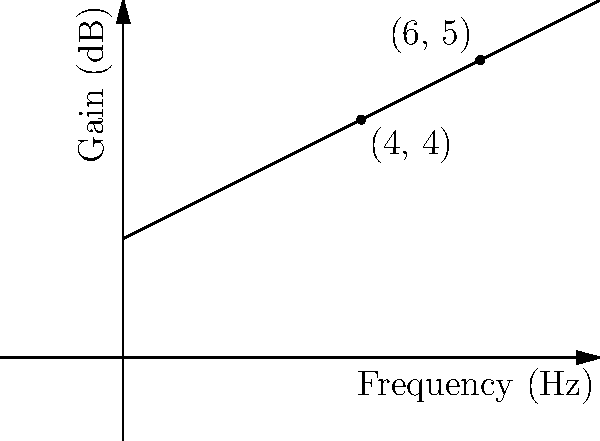An audio equalizer's frequency response is represented by a line on a graph where the x-axis shows frequency in Hz and the y-axis shows gain in dB. Two points on this line are (4, 4) and (6, 5). What is the slope of this line, and what does it represent in terms of the equalizer's response? To find the slope of the line, we'll use the slope formula:

$$ \text{slope} = \frac{y_2 - y_1}{x_2 - x_1} $$

Where $(x_1, y_1)$ is the first point (4, 4) and $(x_2, y_2)$ is the second point (6, 5).

Plugging in the values:

$$ \text{slope} = \frac{5 - 4}{6 - 4} = \frac{1}{2} = 0.5 $$

The slope of 0.5 means that for every 1 Hz increase in frequency, the gain increases by 0.5 dB.

In terms of the equalizer's response, this slope represents the rate of change of gain with respect to frequency. A positive slope indicates that the equalizer is boosting higher frequencies more than lower frequencies, creating a "tilt" in the frequency response towards the treble range.

Specifically, for every octave (doubling of frequency), the gain would increase by:

$$ 0.5 \text{ dB/Hz} \times 1 \text{ Hz} \times \log_2(2) = 0.5 \text{ dB} $$

This is known as a "tilt" or "slope" control in many equalizers, often measured in dB per octave.
Answer: 0.5 dB/Hz, representing a treble boost of 0.5 dB per octave 